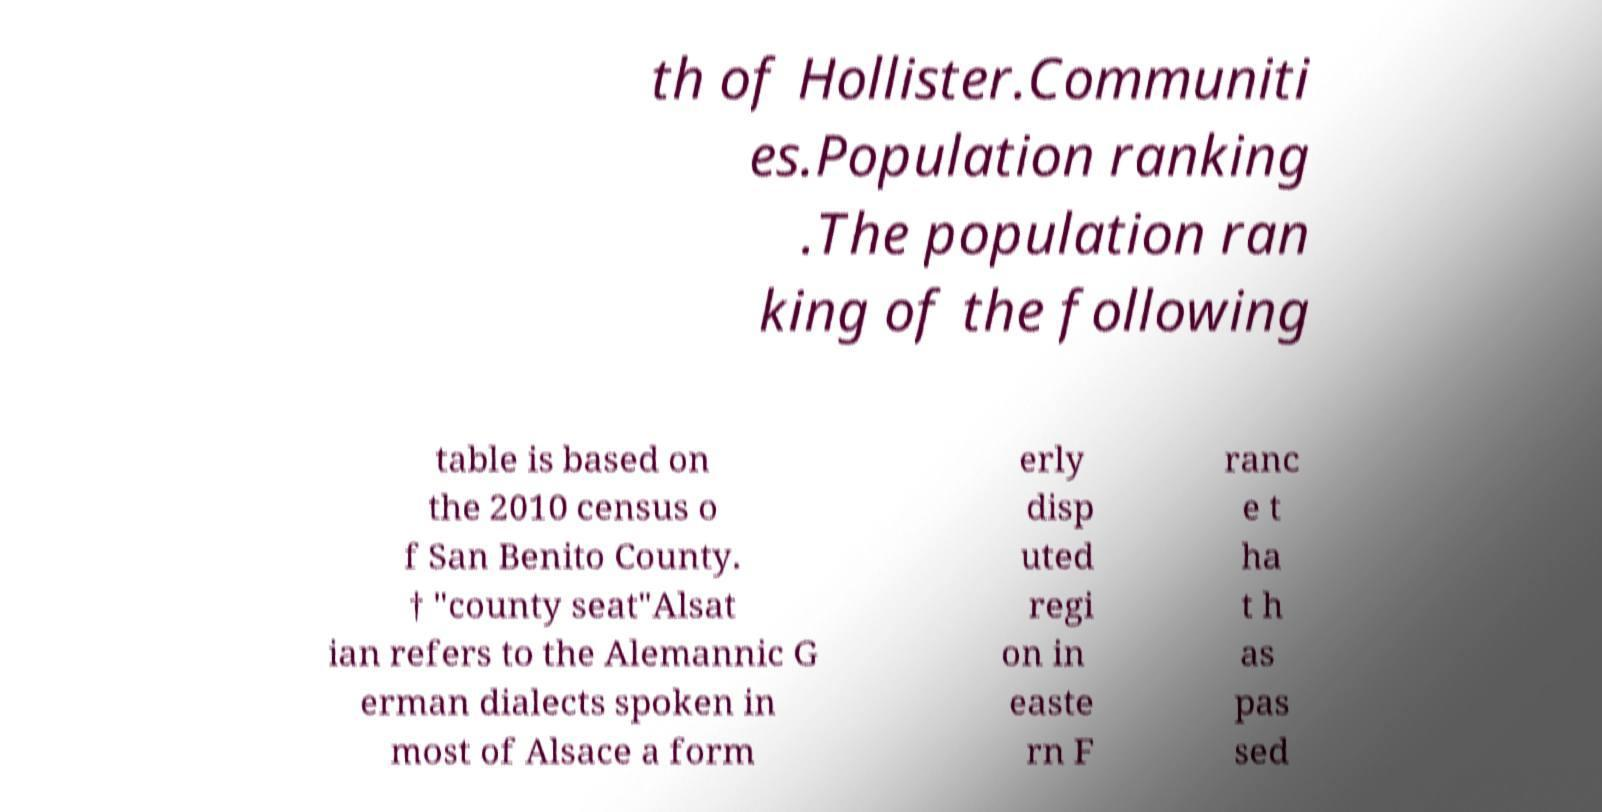What messages or text are displayed in this image? I need them in a readable, typed format. th of Hollister.Communiti es.Population ranking .The population ran king of the following table is based on the 2010 census o f San Benito County. † "county seat"Alsat ian refers to the Alemannic G erman dialects spoken in most of Alsace a form erly disp uted regi on in easte rn F ranc e t ha t h as pas sed 